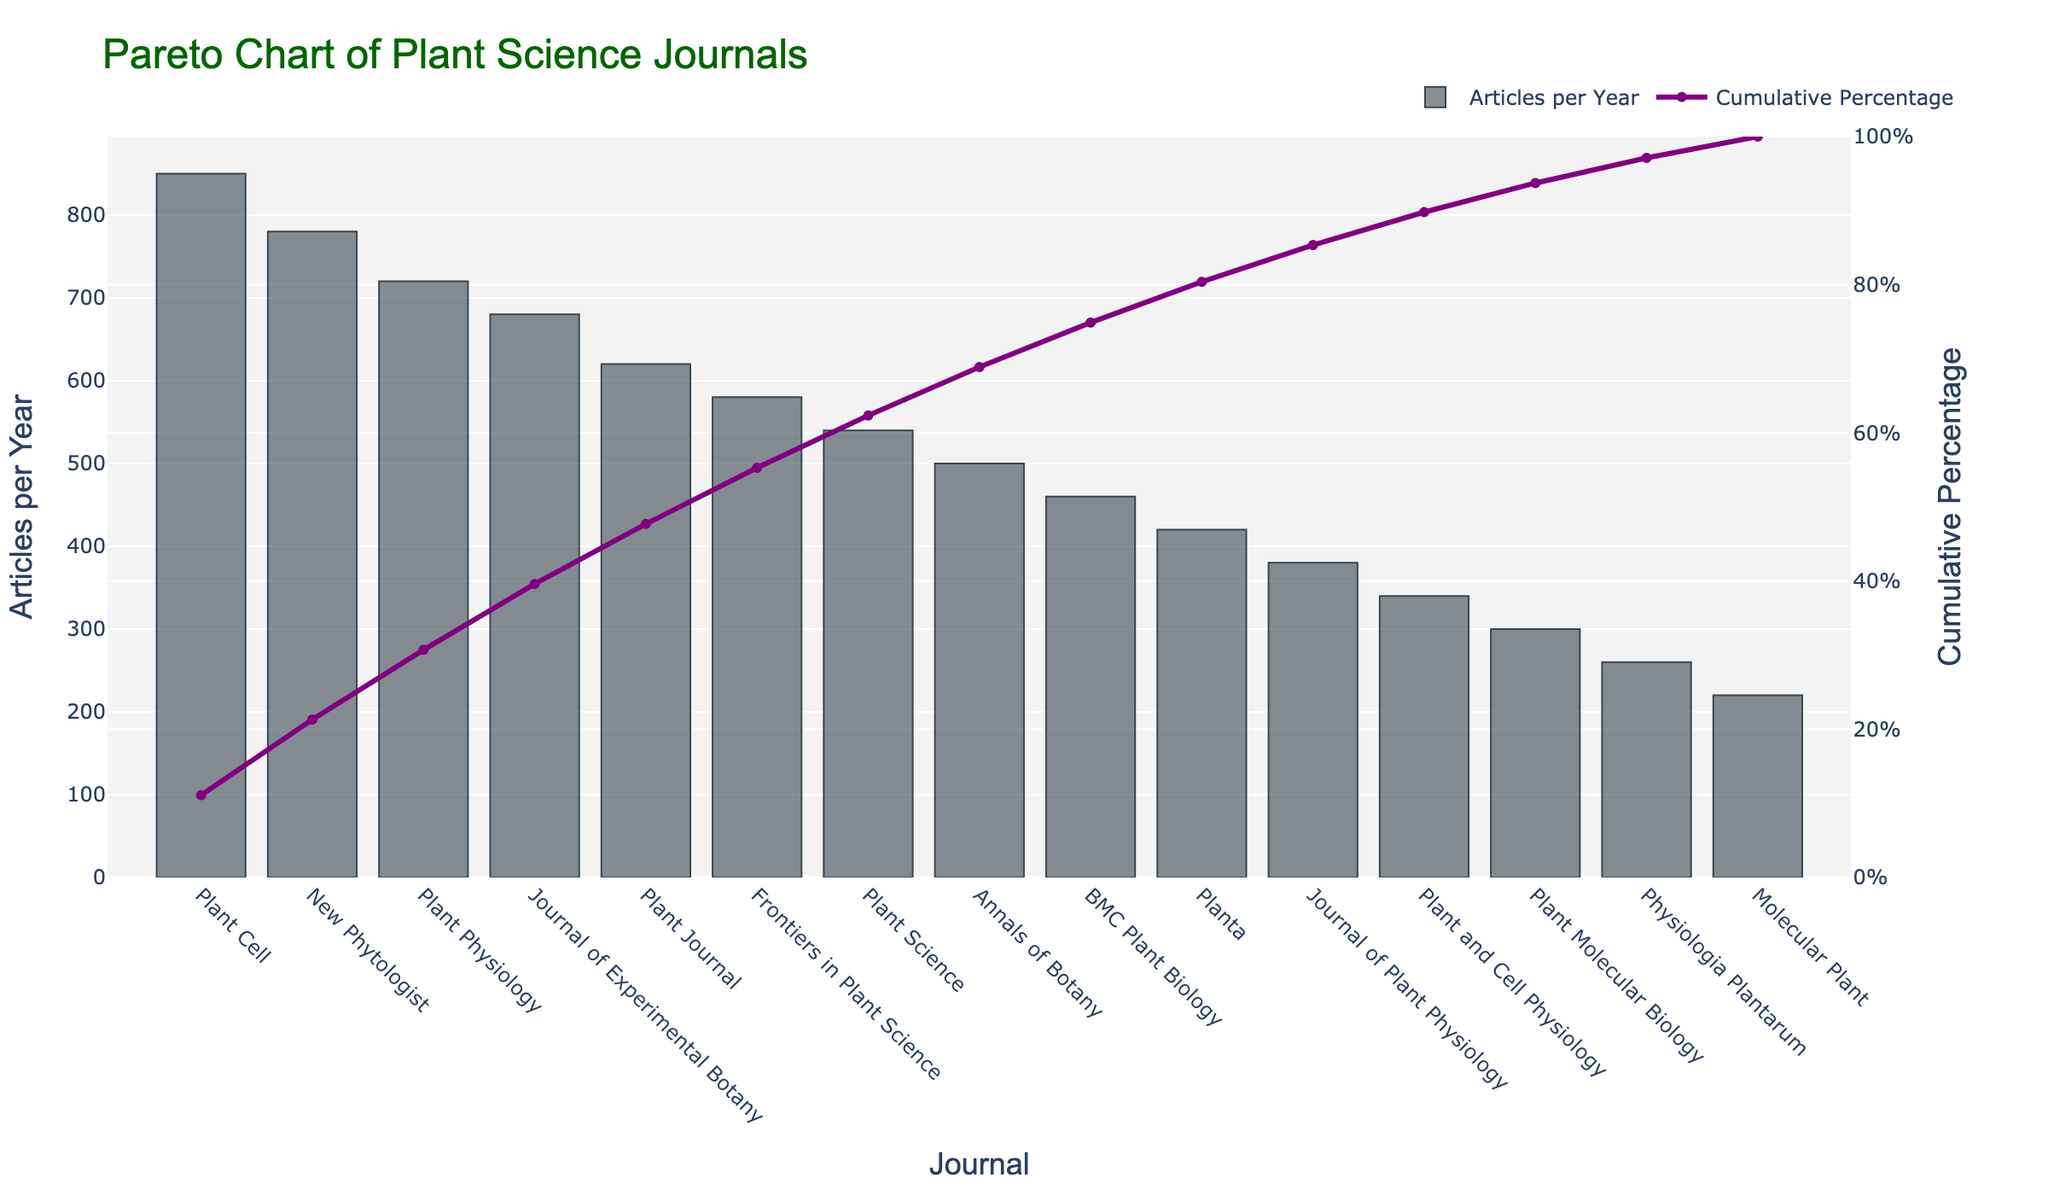what is the title of the figure? The title of the figure is displayed at the top, typically in a larger and distinct font. It usually summarizes the main topic of the plotted data.
Answer: Pareto Chart of Plant Science Journals which journal has the highest number of articles per year? By examining the height of the bars, the tallest bar represents the journal with the highest number of articles per year.
Answer: Plant Cell what is the cumulative percentage for "Plant Journal"? The cumulative percentage for each journal can be found by tracing the line chart. Locate "Plant Journal" on the x-axis and find its corresponding point on the line chart.
Answer: 81.56% how many journals publish more than 500 articles per year? To find the number of journals publishing more than 500 articles per year, count the bars with heights above the 500 mark on the y-axis.
Answer: 5 what color is the cumulative percentage line? The color of the cumulative percentage line can be identified by observing its appearance on the chart.
Answer: Purple what is the difference in the number of articles per year between 'New Phytologist' and 'Plant Physiology'? To find the difference, subtract the number of articles per year of the lower journal from the higher.
Answer: 60 how much is the total contribution (in articles per year) from the top three journals? Sum the articles per year from the top three journals ("Plant Cell", "New Phytologist", and "Plant Physiology") by adding their values together.
Answer: 2350 which journal is ranked fifth in terms of the number of articles per year? Rank the journals based on the heights of the bars, the fifth bar from the left represents the fifth-ranked journal.
Answer: Plant Journal what is the cumulative percentage after 'Frontiers in Plant Science'? Find the corresponding point on the cumulative percentage line after "Frontiers in Plant Science" and read the percentage value.
Answer: 76.1% how does the 'Annals of Botany' compare to 'BMC Plant Biology' in terms of articles per year? Compare the heights of the bars for these two journals to determine which one publishes more articles per year.
Answer: Annals of Botany publishes more 